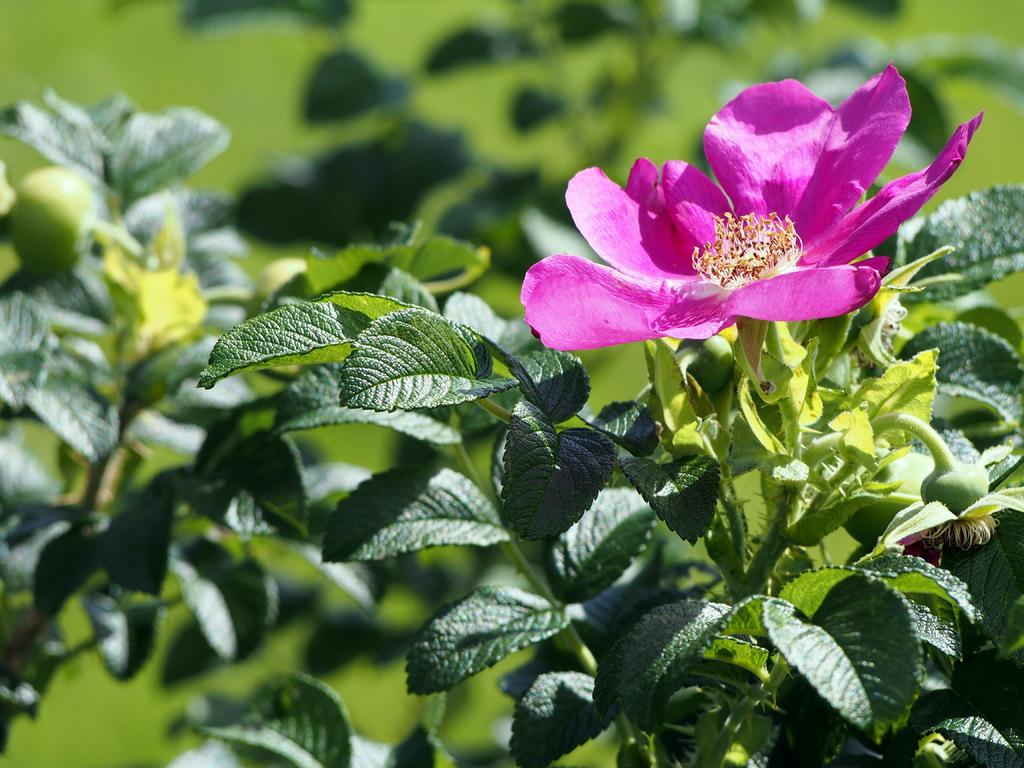What type of living organisms can be seen in the image? Plants can be seen in the image. What color are the flowers on the plants? The flowers on the plants are pink. How many copies of the hat are visible in the image? There is no hat present in the image. How many girls are interacting with the plants in the image? There is no mention of girls in the image; it only features plants with pink flowers. 